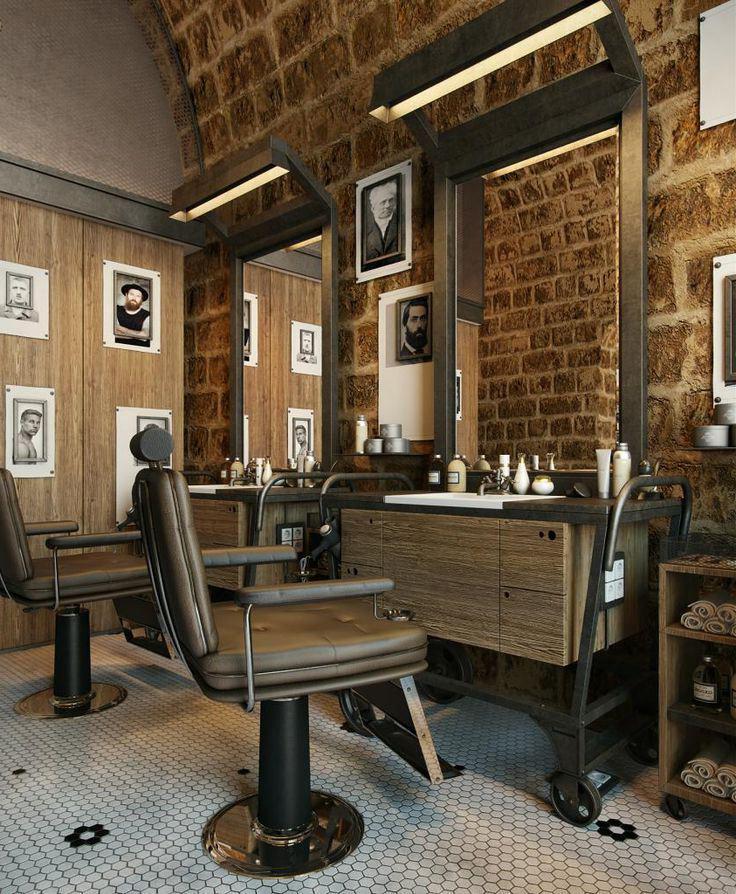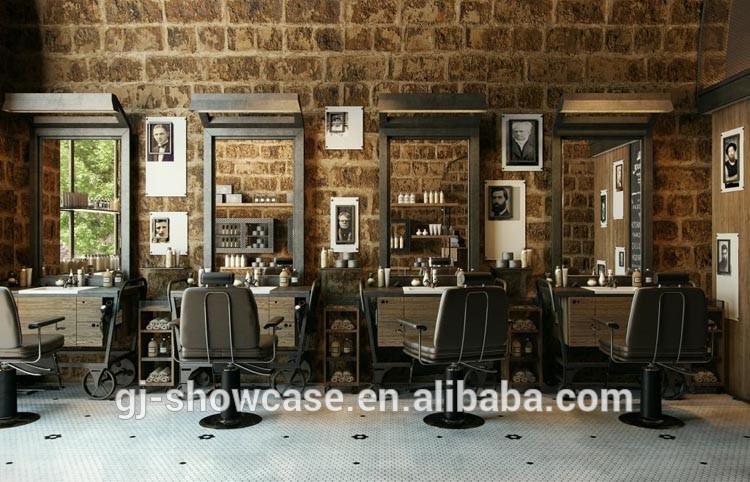The first image is the image on the left, the second image is the image on the right. Given the left and right images, does the statement "In at least one image there is a row of three white circles over a glass nail tables." hold true? Answer yes or no. No. The first image is the image on the left, the second image is the image on the right. Given the left and right images, does the statement "Round mirrors in white frames are suspended in front of dark armchairs from black metal bars, in one image." hold true? Answer yes or no. No. 